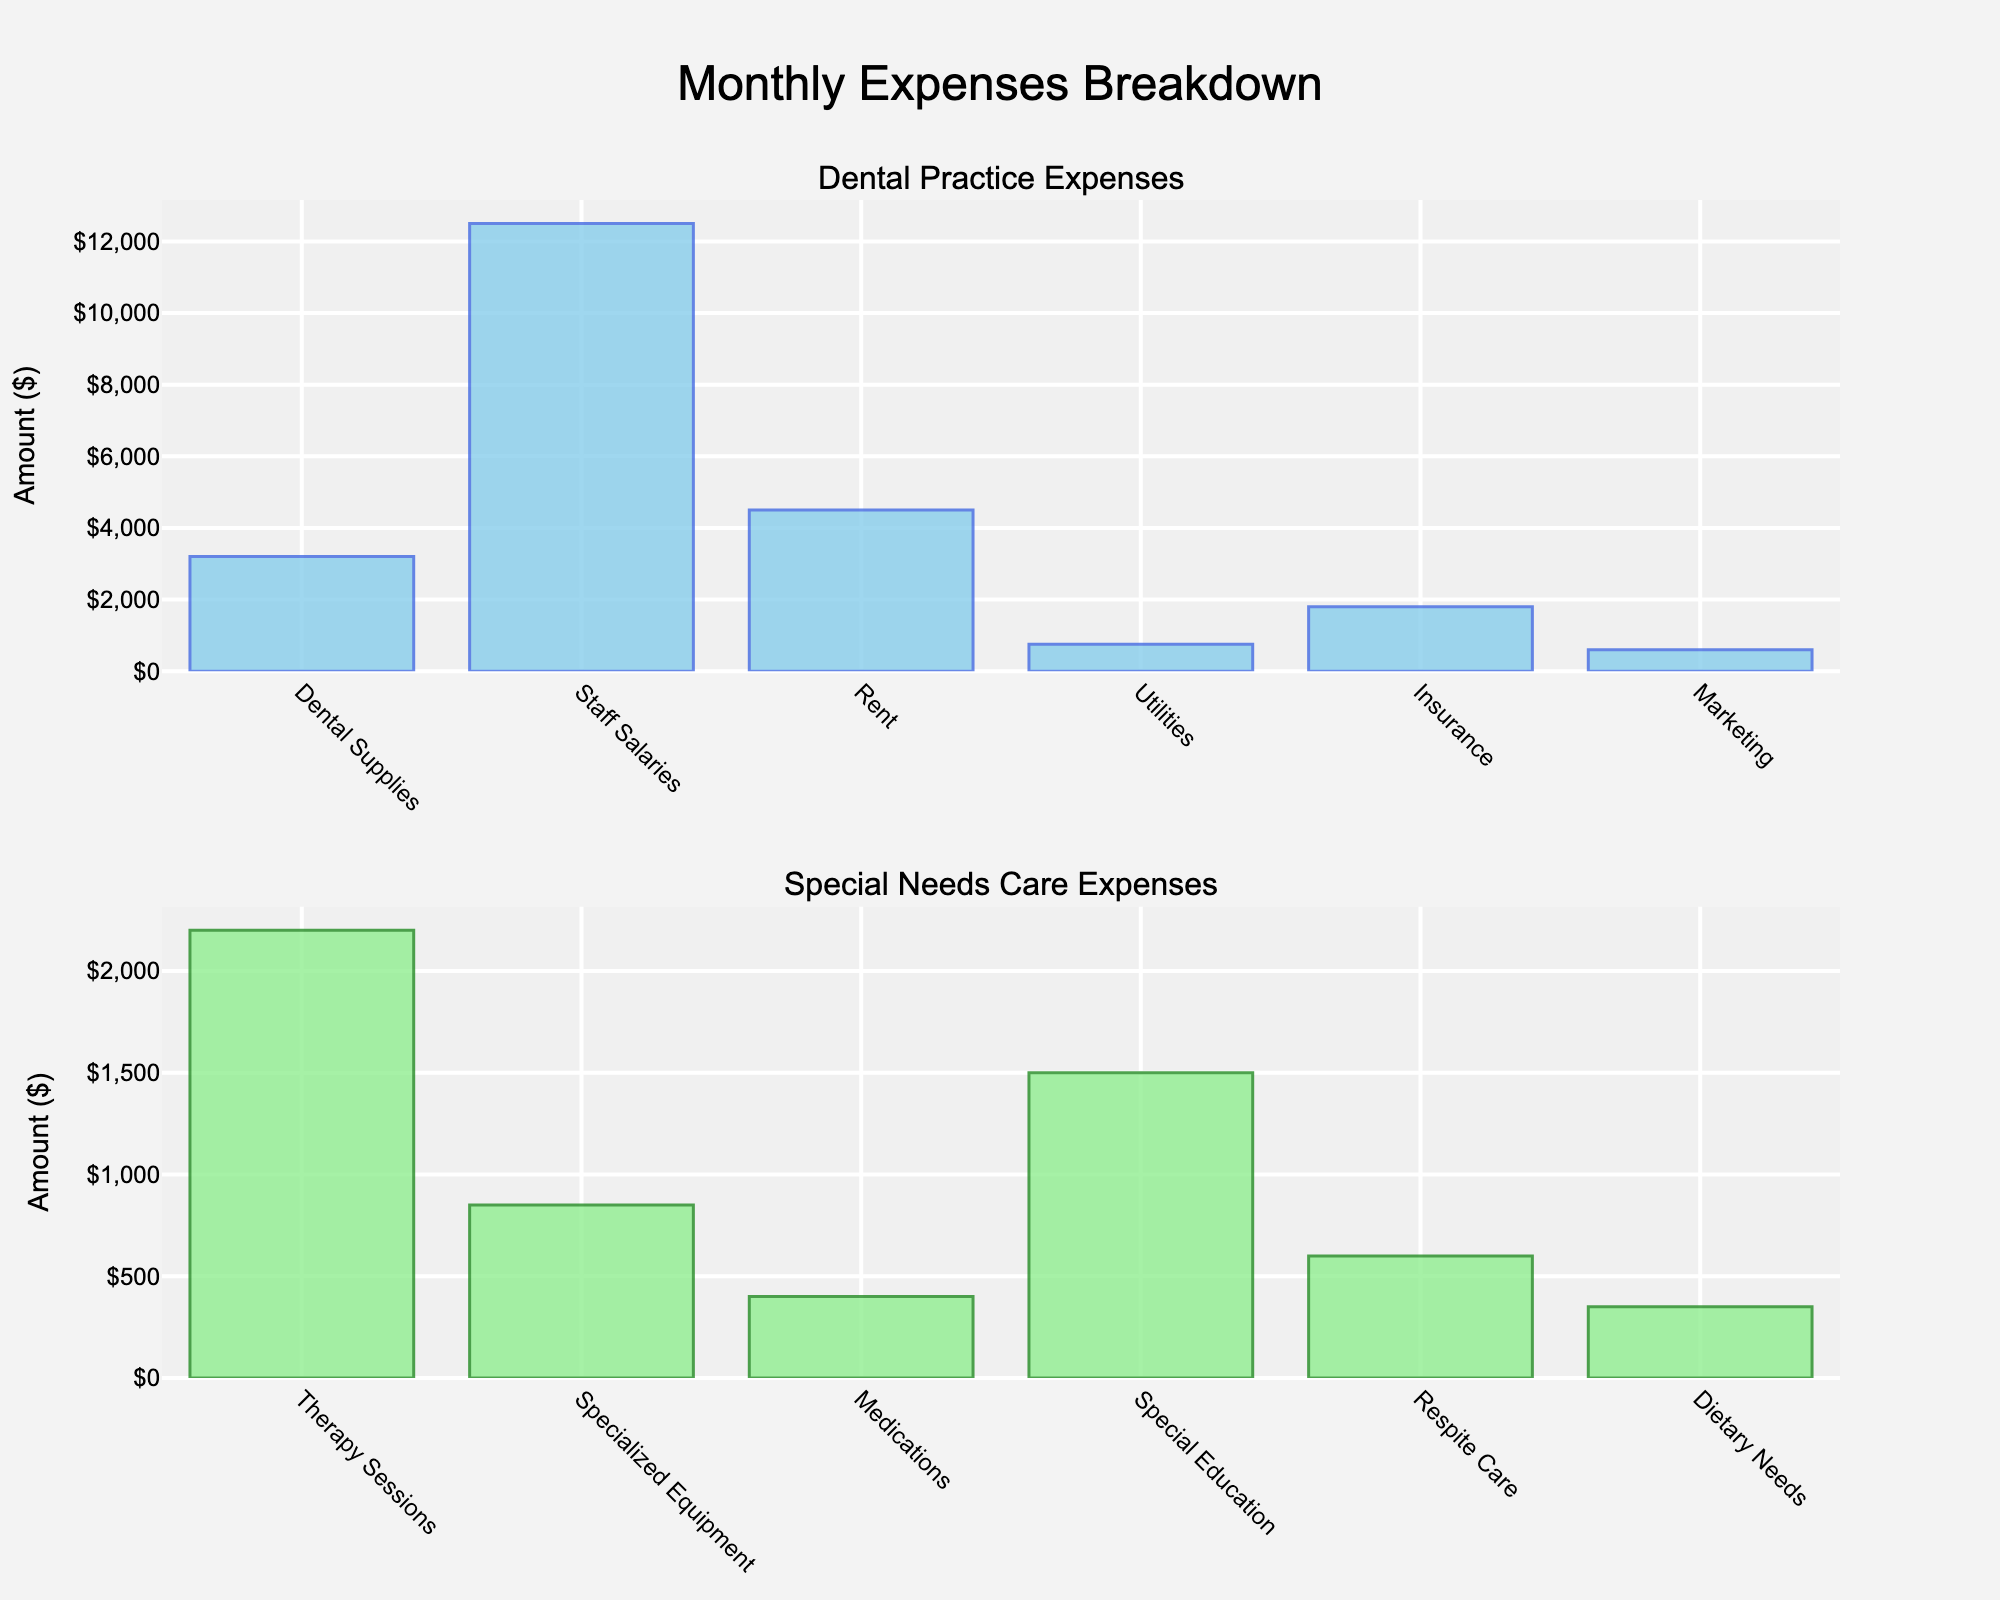How much do Therapy Sessions cost? Therapy Sessions are part of Special Needs Care expenses. Looking at the second subplot labeled "Special Needs Care Expenses," we find that Therapy Sessions cost is $2200.
Answer: $2200 Which category has the highest expense item, and what is it? Checking both subplots: the highest expense in Dental Practice is Staff Salaries at $12,500, and in Special Needs Care, it's Therapy Sessions at $2,200. Staff Salaries in Dental Practice is higher.
Answer: Staff Salaries at $12,500 What is the total monthly expense for Dental Practice? Adding all the amounts in the first subplot labeled "Dental Practice Expenses": $3200 + $12500 + $4500 + $750 + $1800 + $600 = $23,350
Answer: $23,350 Compare the cost of Rent for Dental Practice and Special Education for Special Needs Care. Which is higher? Rent for Dental Practice is $4500, according to the first subplot, whereas Special Education for Special Needs Care is $1500, as shown in the second subplot. Rent is higher.
Answer: Rent for Dental Practice What is the combined monthly expense for Medications and Dietary Needs in Special Needs Care? Adding the amounts for Medications ($400) and Dietary Needs ($350) found in the second subplot: $400 + $350 = $750
Answer: $750 Which expense in the Dental Practice is the lowest? From the first subplot, the expense item with the lowest amount is Marketing, which costs $600.
Answer: Marketing Which category's total monthly expenses are higher, Dental Practice or Special Needs Care? Summing up Special Needs Care expenses: $2200 (Therapy Sessions) + $850 (Specialized Equipment) + $400 (Medications) + $1500 (Special Education) + $600 (Respite Care) + $350 (Dietary Needs) = $5900. Comparing with Dental Practice's total of $23,350, Dental Practice is higher.
Answer: Dental Practice What is the average expense for Staff Salaries, Rent, and Insurance in Dental Practice? Adding the selected expenses: $12500 (Staff Salaries) + $4500 (Rent) + $1800 (Insurance) = $18,800. Dividing by 3 to get average: $18,800 / 3 ≈ $6266.67
Answer: $6266.67 Are the expenses for Dental Supplies and Respite Care the same? Dental Supplies cost $3200 (first subplot), whereas Respite Care costs $600 (second subplot). These expenses are not the same.
Answer: No How does the cost for Insurance in Dental Practice compare to Specialized Equipment in Special Needs Care? Insurance cost in Dental Practice is $1800, while Specialized Equipment in Special Needs Care is $850. Insurance costs more.
Answer: Insurance costs more 